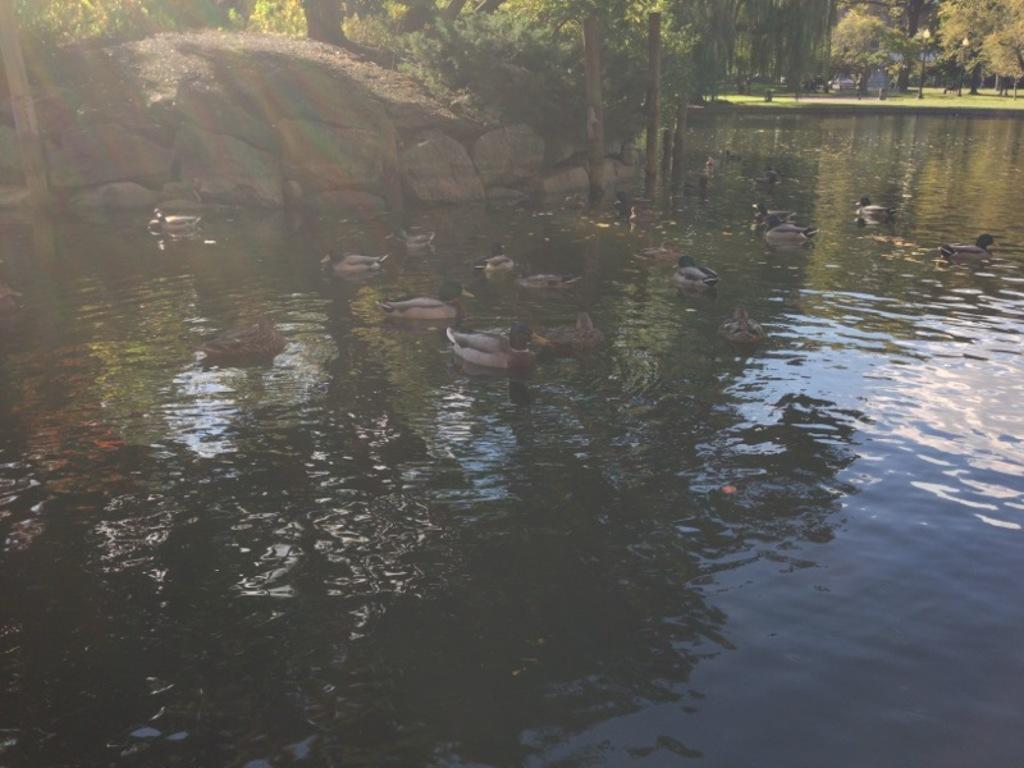What animals can be seen in the water in the image? There are ducks swimming in the water in the image. What is the primary element in which the ducks are situated? The ducks are situated in water. What can be seen in the background of the image? There are trees and grass in the background of the image. What type of songs is the band playing in the background of the image? There is no band present in the image, so it is not possible to determine what type of songs might be played. 